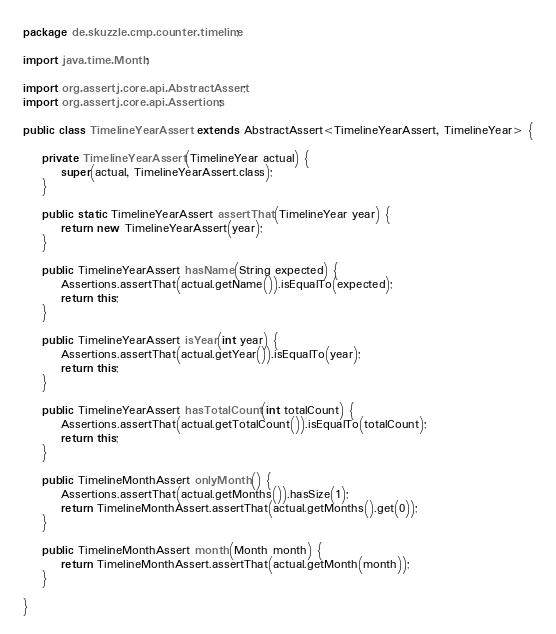<code> <loc_0><loc_0><loc_500><loc_500><_Java_>package de.skuzzle.cmp.counter.timeline;

import java.time.Month;

import org.assertj.core.api.AbstractAssert;
import org.assertj.core.api.Assertions;

public class TimelineYearAssert extends AbstractAssert<TimelineYearAssert, TimelineYear> {

    private TimelineYearAssert(TimelineYear actual) {
        super(actual, TimelineYearAssert.class);
    }

    public static TimelineYearAssert assertThat(TimelineYear year) {
        return new TimelineYearAssert(year);
    }

    public TimelineYearAssert hasName(String expected) {
        Assertions.assertThat(actual.getName()).isEqualTo(expected);
        return this;
    }

    public TimelineYearAssert isYear(int year) {
        Assertions.assertThat(actual.getYear()).isEqualTo(year);
        return this;
    }

    public TimelineYearAssert hasTotalCount(int totalCount) {
        Assertions.assertThat(actual.getTotalCount()).isEqualTo(totalCount);
        return this;
    }

    public TimelineMonthAssert onlyMonth() {
        Assertions.assertThat(actual.getMonths()).hasSize(1);
        return TimelineMonthAssert.assertThat(actual.getMonths().get(0));
    }

    public TimelineMonthAssert month(Month month) {
        return TimelineMonthAssert.assertThat(actual.getMonth(month));
    }

}
</code> 